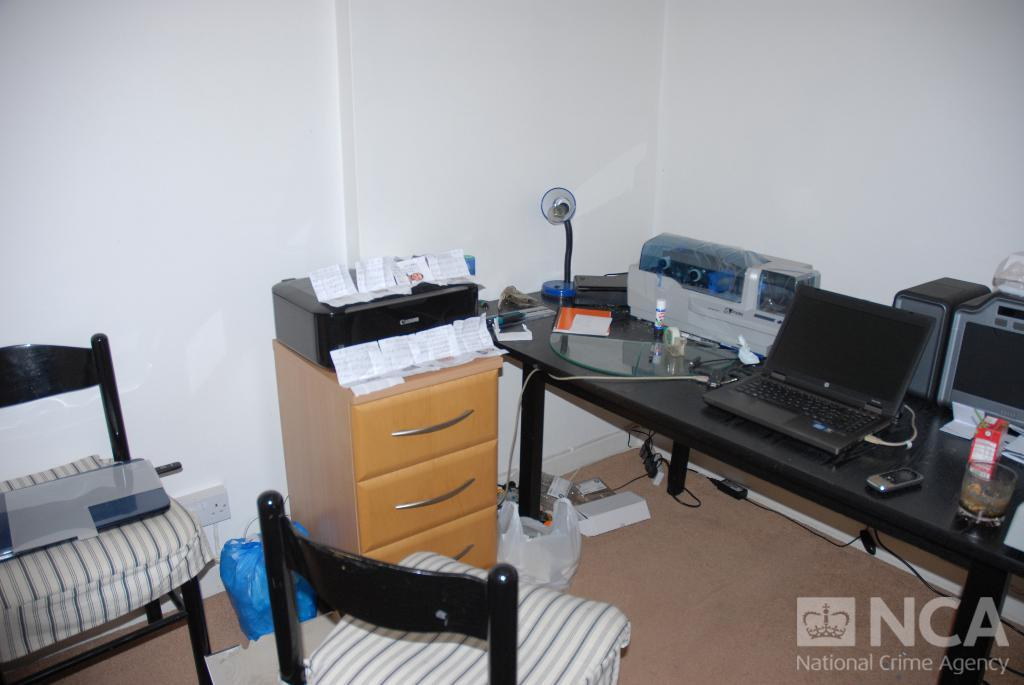What electronic device is on the table in the image? There is a laptop on the table in the image. What other office equipment is on the table? There is a printer and a table lamp on the table in the image. What other items are on the table? There are other articles on the table in the image. Where is the second printer located? The second printer is on a set of drawers in the image. What is on the chair in the image? There is another laptop on a chair in the image. What type of books are displayed on the table in the image? There are no books visible in the image. How does the territory of the office space expand in the image? The image does not depict any changes in territory or expansion of the office space. 